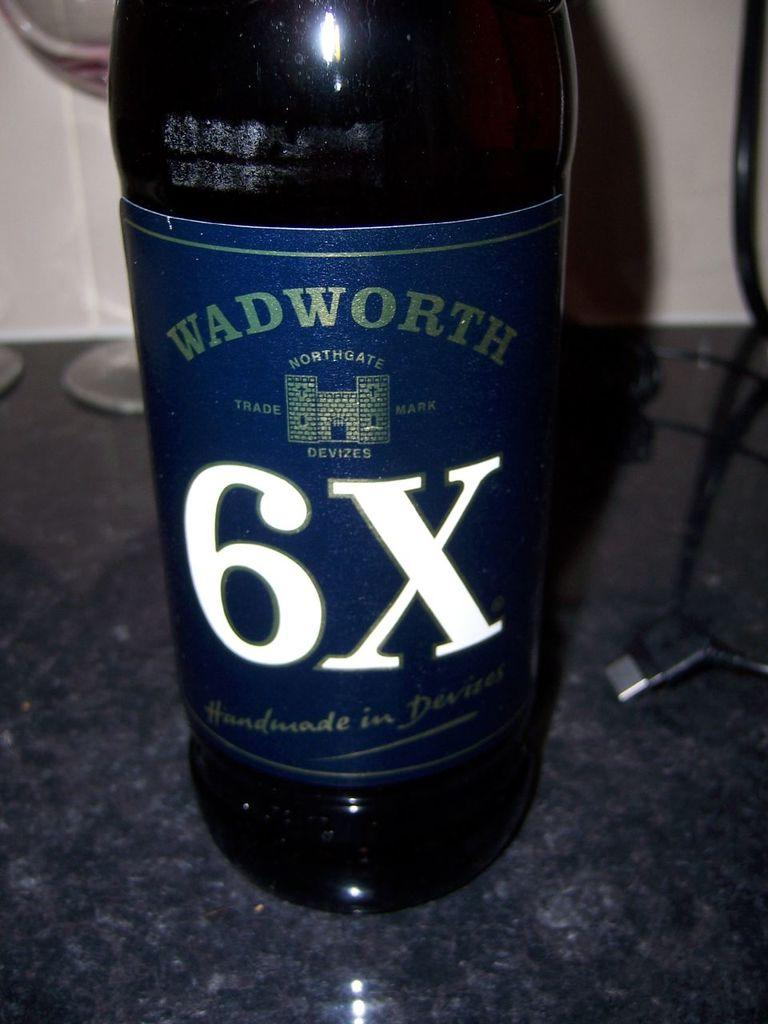<image>
Give a short and clear explanation of the subsequent image. A bottle of WADWORTH 6X sits on a table with a phone charger. 